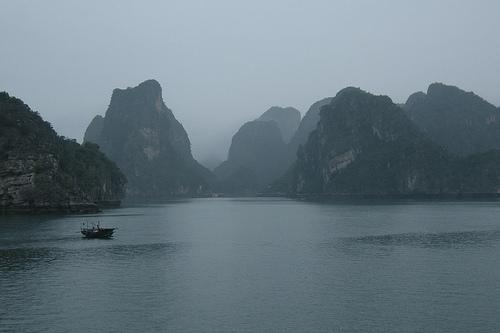Explain the central focus of the image in a short sentence. A small vessel tackles the expanse of a lake peppered with rocky formations and shrouded in gray. Write a short rhyming couplet about the image. Through a fogged realm of rocks and dark cloudy trails In one sentence, describe the atmosphere of the scene in the image. The image conveys a tranquil yet mysterious atmosphere with a boat gliding through foggy waters. Use metaphors to describe the image in an artistic manner. The lone boat weaves through the rock-studded tapestry of the murky lake, under the watchful eye of an enigmatic, cloudy sky. Write a haiku inspired by the image. Gray sky whispers peace Provide a brief description of the primary elements in the image. A small boat sails through calm, murky water surrounded by large rock formations and trees, under a cloudy gray sky. Describe the main components of the image and their interactions in a creative manner. Under the cloak of misty skies, a solitary boat slices through the water, delicately navigating past enigmatic rock guardians adorned with verdant foliage. Mention the key highlights of the picture in a sentence. A lone boat traverses the lake amidst ripples, rock formations, trees, and a foggy sky. Describe the still image like a snapshot from a movie scene. In the fog-enshrouded land of mystery, the small boat silently sails on, navigating its way past the rocky behemoths that bore witness to its solitary journey. Imagine you are a poet and describe the scene in the image. A boat drifts in solitude, navigating waters bound by nature's stony embrace, while a moody sky casts its silent gaze. 